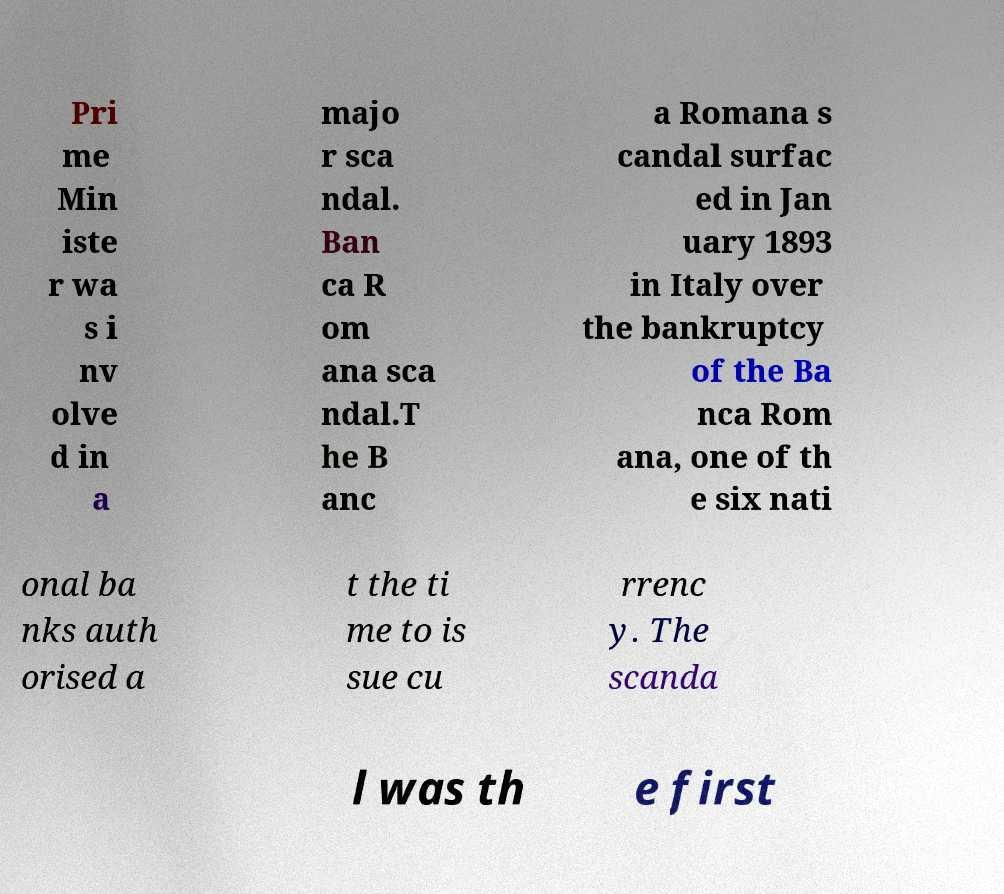Can you accurately transcribe the text from the provided image for me? Pri me Min iste r wa s i nv olve d in a majo r sca ndal. Ban ca R om ana sca ndal.T he B anc a Romana s candal surfac ed in Jan uary 1893 in Italy over the bankruptcy of the Ba nca Rom ana, one of th e six nati onal ba nks auth orised a t the ti me to is sue cu rrenc y. The scanda l was th e first 